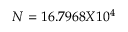Convert formula to latex. <formula><loc_0><loc_0><loc_500><loc_500>N = 1 6 . 7 9 6 8 X 1 0 ^ { 4 }</formula> 